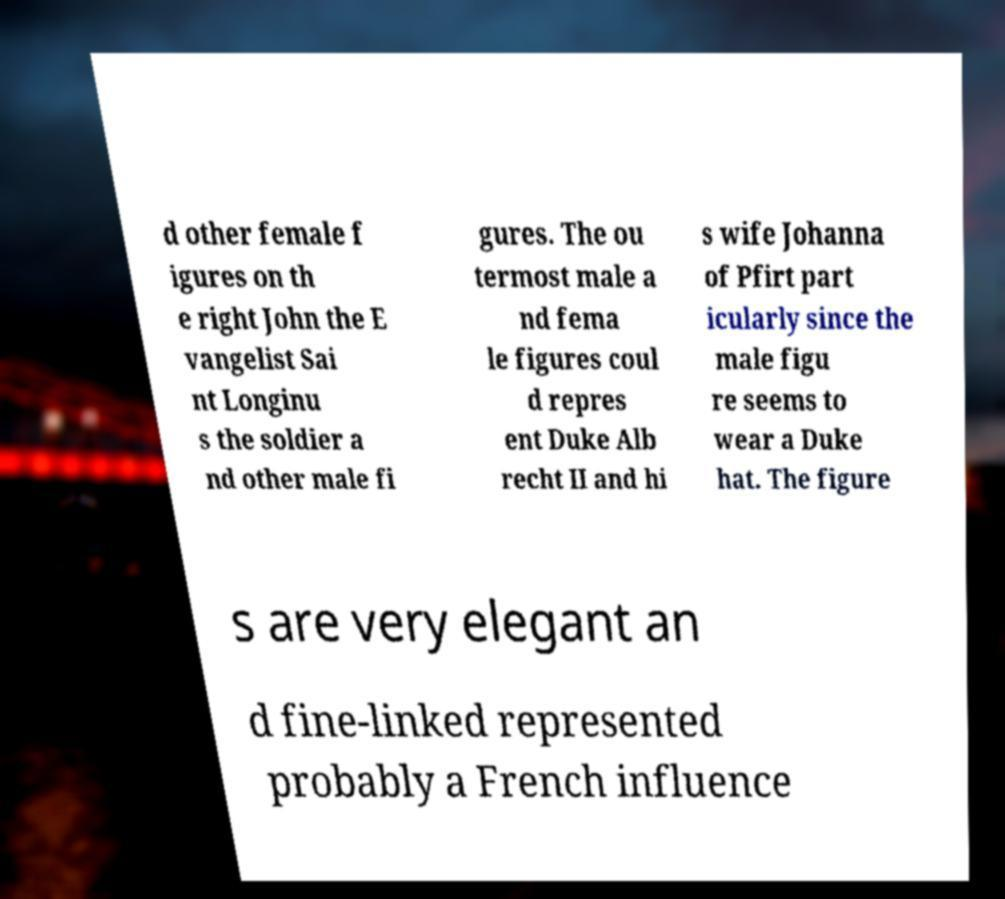Please read and relay the text visible in this image. What does it say? d other female f igures on th e right John the E vangelist Sai nt Longinu s the soldier a nd other male fi gures. The ou termost male a nd fema le figures coul d repres ent Duke Alb recht II and hi s wife Johanna of Pfirt part icularly since the male figu re seems to wear a Duke hat. The figure s are very elegant an d fine-linked represented probably a French influence 